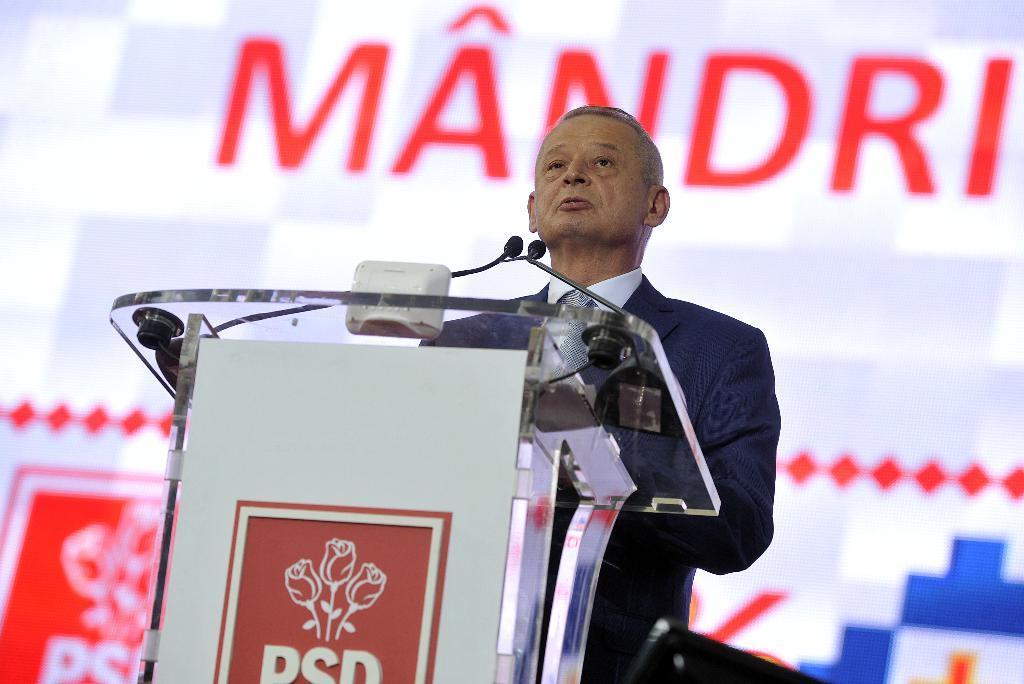Could you give a brief overview of what you see in this image? In this image, we can see a person. We can also see a podium. We can see some microphones and a board with some text and image. In the background, we can see the wall with some text and images. 